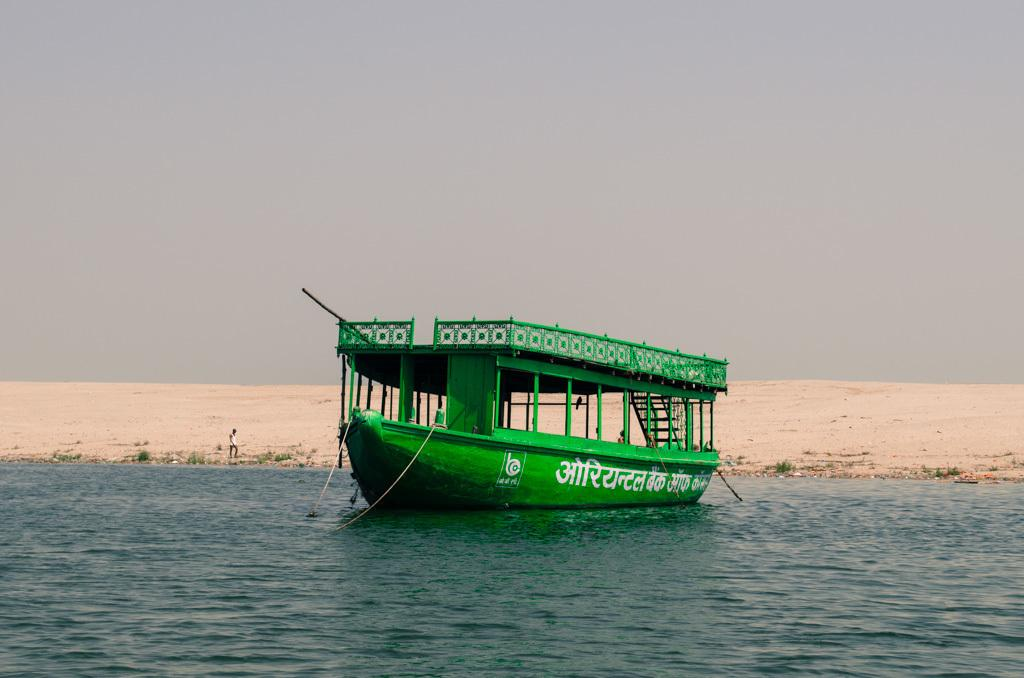What type of boat is in the image? There is a green color boat in the image. What is the boat situated on or in? The boat is on water, which is visible at the bottom of the image. What else can be seen in the image besides the boat? The sky is visible at the top of the image. What type of songs can be heard coming from the boat in the image? There is no indication in the image that any songs are being played or heard from the boat. 